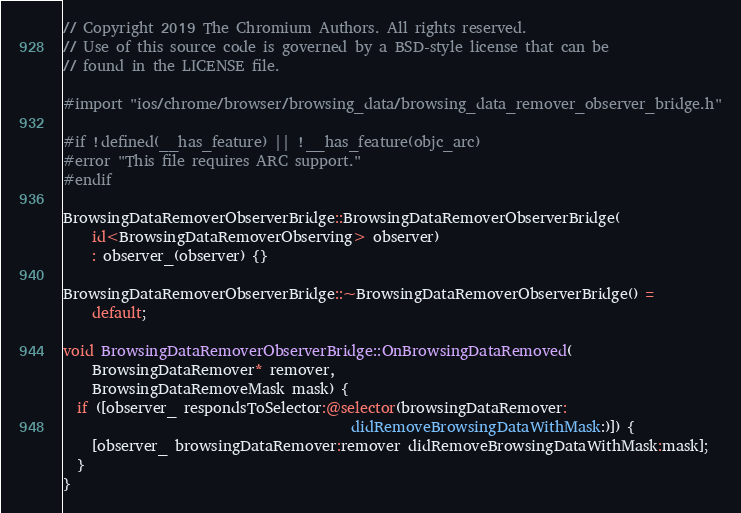Convert code to text. <code><loc_0><loc_0><loc_500><loc_500><_ObjectiveC_>// Copyright 2019 The Chromium Authors. All rights reserved.
// Use of this source code is governed by a BSD-style license that can be
// found in the LICENSE file.

#import "ios/chrome/browser/browsing_data/browsing_data_remover_observer_bridge.h"

#if !defined(__has_feature) || !__has_feature(objc_arc)
#error "This file requires ARC support."
#endif

BrowsingDataRemoverObserverBridge::BrowsingDataRemoverObserverBridge(
    id<BrowsingDataRemoverObserving> observer)
    : observer_(observer) {}

BrowsingDataRemoverObserverBridge::~BrowsingDataRemoverObserverBridge() =
    default;

void BrowsingDataRemoverObserverBridge::OnBrowsingDataRemoved(
    BrowsingDataRemover* remover,
    BrowsingDataRemoveMask mask) {
  if ([observer_ respondsToSelector:@selector(browsingDataRemover:
                                        didRemoveBrowsingDataWithMask:)]) {
    [observer_ browsingDataRemover:remover didRemoveBrowsingDataWithMask:mask];
  }
}
</code> 